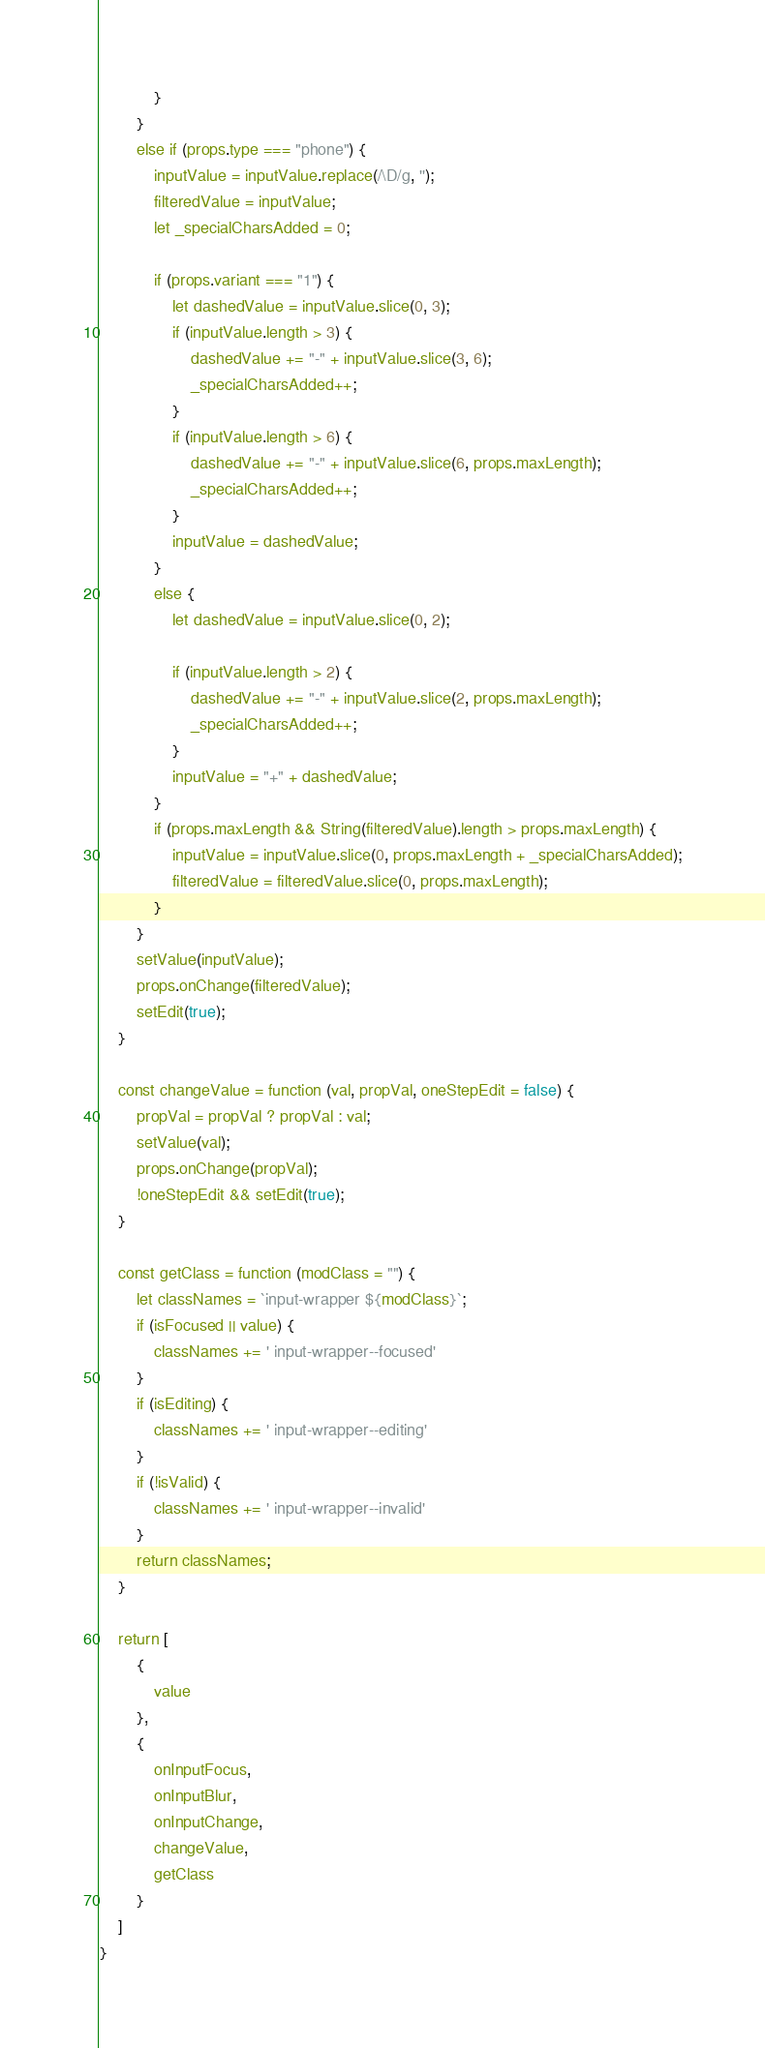<code> <loc_0><loc_0><loc_500><loc_500><_JavaScript_>            }
        }
        else if (props.type === "phone") {
            inputValue = inputValue.replace(/\D/g, '');
            filteredValue = inputValue;
            let _specialCharsAdded = 0;

            if (props.variant === "1") {
                let dashedValue = inputValue.slice(0, 3);
                if (inputValue.length > 3) {
                    dashedValue += "-" + inputValue.slice(3, 6);
                    _specialCharsAdded++;
                }
                if (inputValue.length > 6) {
                    dashedValue += "-" + inputValue.slice(6, props.maxLength);
                    _specialCharsAdded++;
                }
                inputValue = dashedValue;
            }
            else {
                let dashedValue = inputValue.slice(0, 2);

                if (inputValue.length > 2) {
                    dashedValue += "-" + inputValue.slice(2, props.maxLength);
                    _specialCharsAdded++;
                }
                inputValue = "+" + dashedValue;
            }
            if (props.maxLength && String(filteredValue).length > props.maxLength) {
                inputValue = inputValue.slice(0, props.maxLength + _specialCharsAdded);
                filteredValue = filteredValue.slice(0, props.maxLength);
            }
        }
        setValue(inputValue);
        props.onChange(filteredValue);
        setEdit(true);
    }

    const changeValue = function (val, propVal, oneStepEdit = false) {
        propVal = propVal ? propVal : val;
        setValue(val);
        props.onChange(propVal);
        !oneStepEdit && setEdit(true);
    }

    const getClass = function (modClass = "") {
        let classNames = `input-wrapper ${modClass}`;
        if (isFocused || value) {
            classNames += ' input-wrapper--focused'
        }
        if (isEditing) {
            classNames += ' input-wrapper--editing'
        }
        if (!isValid) {
            classNames += ' input-wrapper--invalid'
        }
        return classNames;
    }

    return [
        {
            value
        },
        {
            onInputFocus,
            onInputBlur,
            onInputChange,
            changeValue,
            getClass
        }
    ]
}</code> 